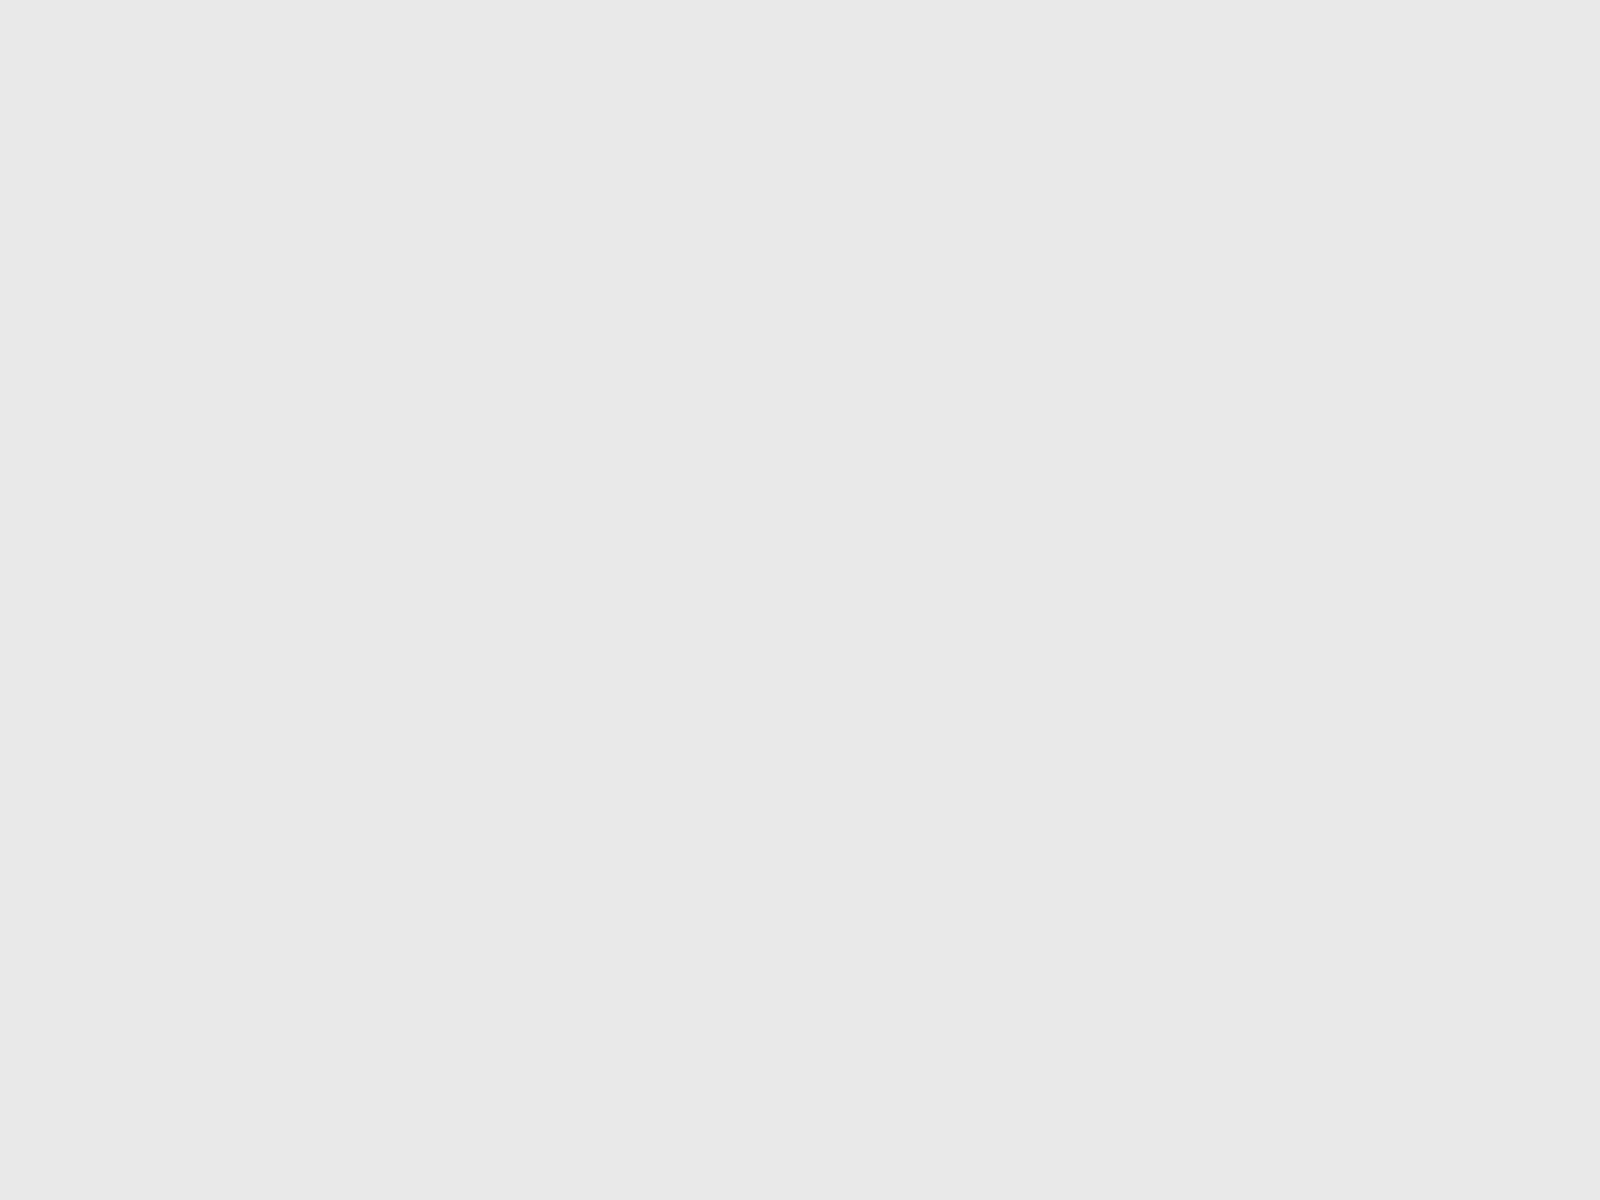Convert chart. <chart><loc_0><loc_0><loc_500><loc_500><pie_chart><fcel>Non-vested at January 1 2012<fcel>Granted<fcel>Adjustment<fcel>Vested<fcel>Non-vested at December 31 2012<nl><fcel>32.43%<fcel>10.81%<fcel>5.41%<fcel>16.22%<fcel>35.14%<nl></chart> 